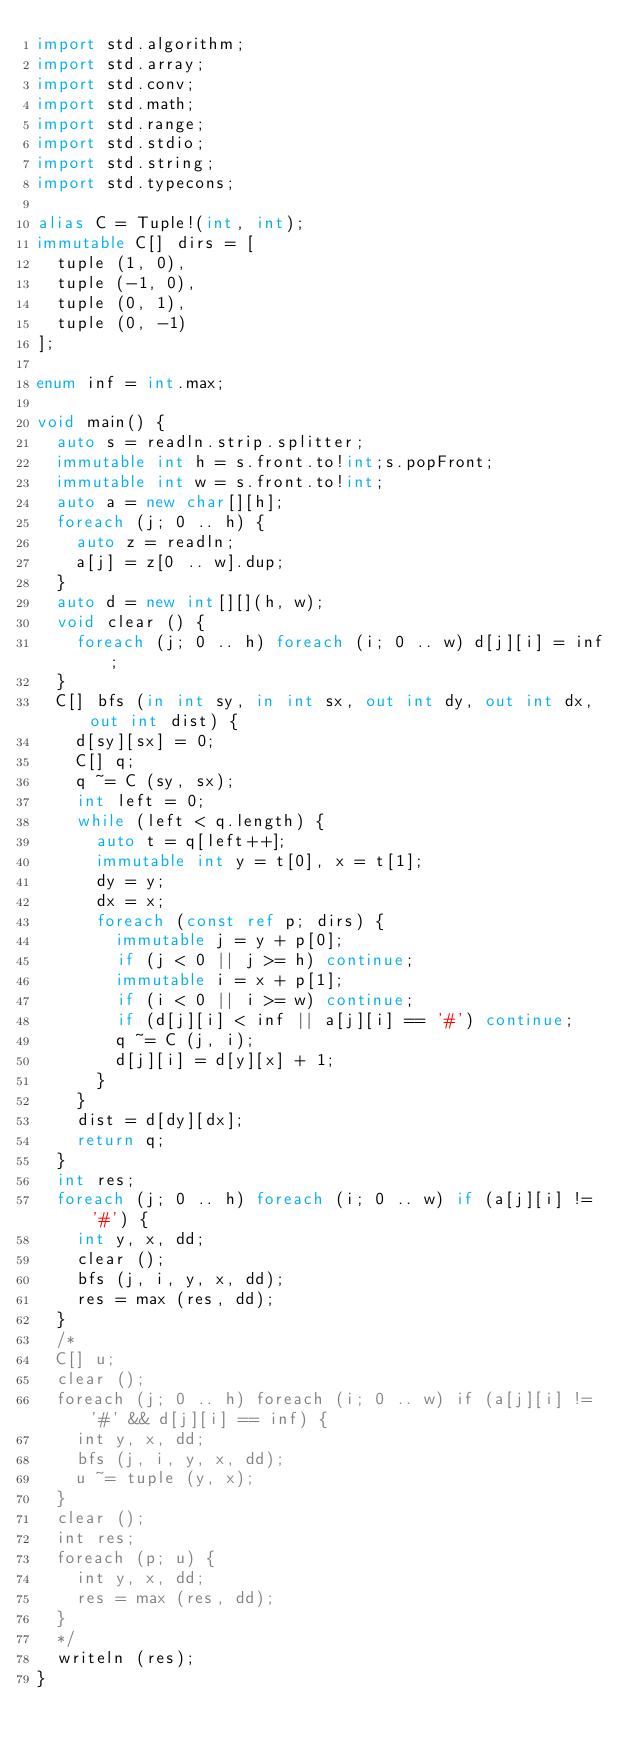Convert code to text. <code><loc_0><loc_0><loc_500><loc_500><_D_>import std.algorithm;
import std.array;
import std.conv;
import std.math;
import std.range;
import std.stdio;
import std.string;
import std.typecons;

alias C = Tuple!(int, int);
immutable C[] dirs = [
  tuple (1, 0),
  tuple (-1, 0),
  tuple (0, 1),
  tuple (0, -1)
];

enum inf = int.max; 

void main() {
  auto s = readln.strip.splitter;
  immutable int h = s.front.to!int;s.popFront;
  immutable int w = s.front.to!int;
  auto a = new char[][h];
  foreach (j; 0 .. h) {
    auto z = readln;
    a[j] = z[0 .. w].dup;
  }
  auto d = new int[][](h, w);
  void clear () {
    foreach (j; 0 .. h) foreach (i; 0 .. w) d[j][i] = inf;
  }
  C[] bfs (in int sy, in int sx, out int dy, out int dx, out int dist) {
    d[sy][sx] = 0;
    C[] q;
    q ~= C (sy, sx);
    int left = 0;
    while (left < q.length) {
      auto t = q[left++];
      immutable int y = t[0], x = t[1];
      dy = y;
      dx = x;
      foreach (const ref p; dirs) {
        immutable j = y + p[0];
        if (j < 0 || j >= h) continue;
        immutable i = x + p[1];
        if (i < 0 || i >= w) continue;
        if (d[j][i] < inf || a[j][i] == '#') continue;
        q ~= C (j, i);
        d[j][i] = d[y][x] + 1;
      }
    }
    dist = d[dy][dx];
    return q;
  }
  int res;
  foreach (j; 0 .. h) foreach (i; 0 .. w) if (a[j][i] != '#') {
    int y, x, dd;
    clear ();
    bfs (j, i, y, x, dd); 
    res = max (res, dd);
  }
  /*
  C[] u;
  clear ();
  foreach (j; 0 .. h) foreach (i; 0 .. w) if (a[j][i] != '#' && d[j][i] == inf) {
    int y, x, dd;
    bfs (j, i, y, x, dd); 
    u ~= tuple (y, x);
  }
  clear ();
  int res;
  foreach (p; u) {
    int y, x, dd;
    res = max (res, dd);
  }
  */
  writeln (res);
}

</code> 